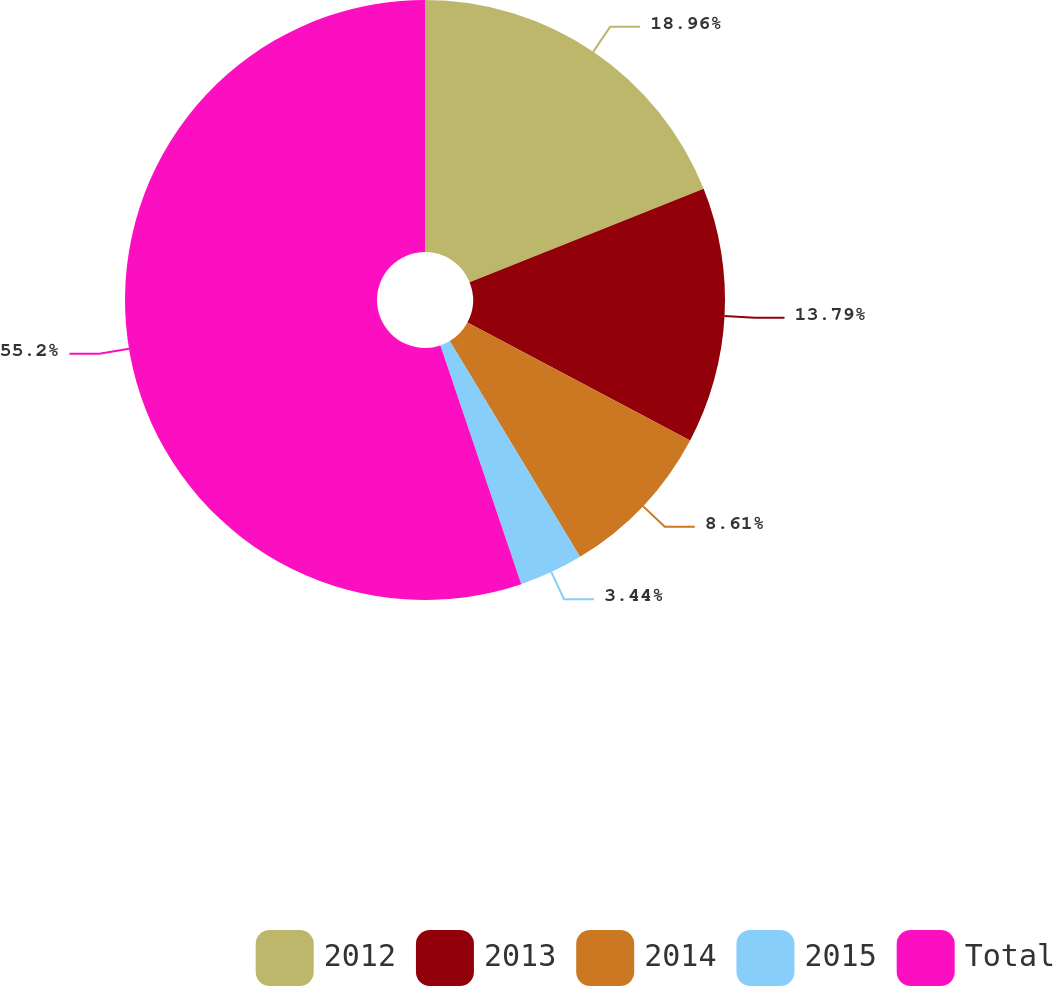Convert chart to OTSL. <chart><loc_0><loc_0><loc_500><loc_500><pie_chart><fcel>2012<fcel>2013<fcel>2014<fcel>2015<fcel>Total<nl><fcel>18.96%<fcel>13.79%<fcel>8.61%<fcel>3.44%<fcel>55.2%<nl></chart> 